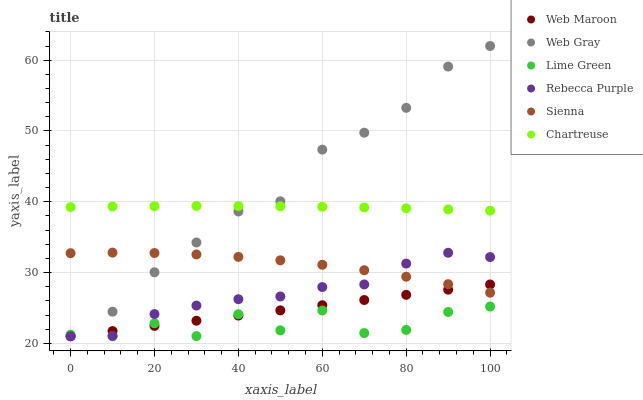Does Lime Green have the minimum area under the curve?
Answer yes or no. Yes. Does Web Gray have the maximum area under the curve?
Answer yes or no. Yes. Does Web Maroon have the minimum area under the curve?
Answer yes or no. No. Does Web Maroon have the maximum area under the curve?
Answer yes or no. No. Is Web Maroon the smoothest?
Answer yes or no. Yes. Is Lime Green the roughest?
Answer yes or no. Yes. Is Sienna the smoothest?
Answer yes or no. No. Is Sienna the roughest?
Answer yes or no. No. Does Web Gray have the lowest value?
Answer yes or no. Yes. Does Sienna have the lowest value?
Answer yes or no. No. Does Web Gray have the highest value?
Answer yes or no. Yes. Does Web Maroon have the highest value?
Answer yes or no. No. Is Lime Green less than Chartreuse?
Answer yes or no. Yes. Is Chartreuse greater than Sienna?
Answer yes or no. Yes. Does Sienna intersect Rebecca Purple?
Answer yes or no. Yes. Is Sienna less than Rebecca Purple?
Answer yes or no. No. Is Sienna greater than Rebecca Purple?
Answer yes or no. No. Does Lime Green intersect Chartreuse?
Answer yes or no. No. 